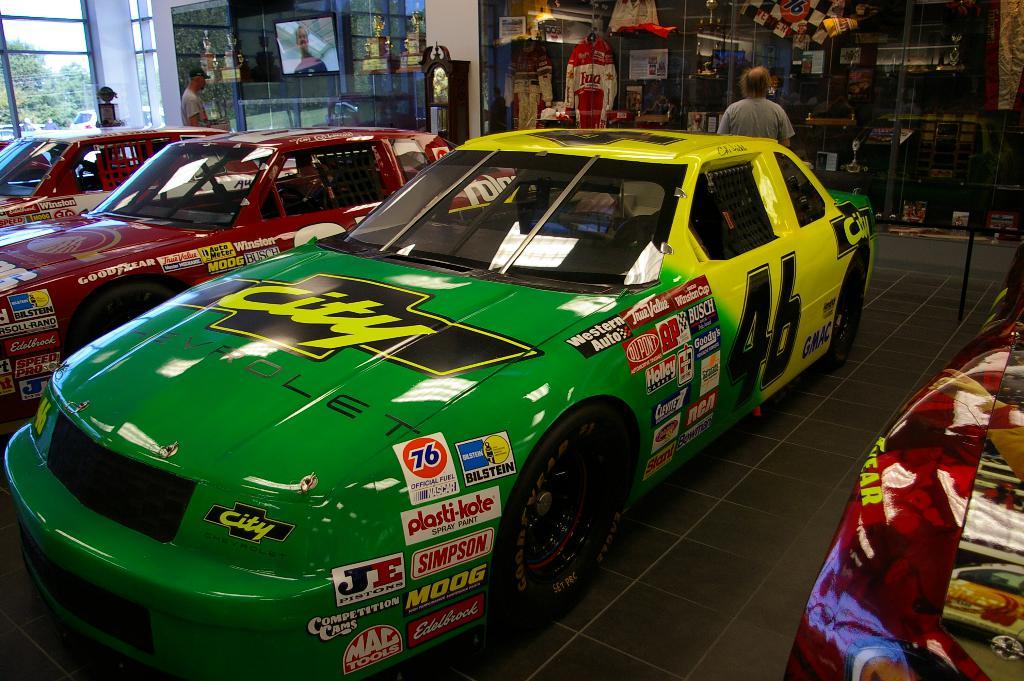What is the car number?
Your answer should be compact. 46. What brands are shown on the green car?
Your answer should be very brief. Simpson. 